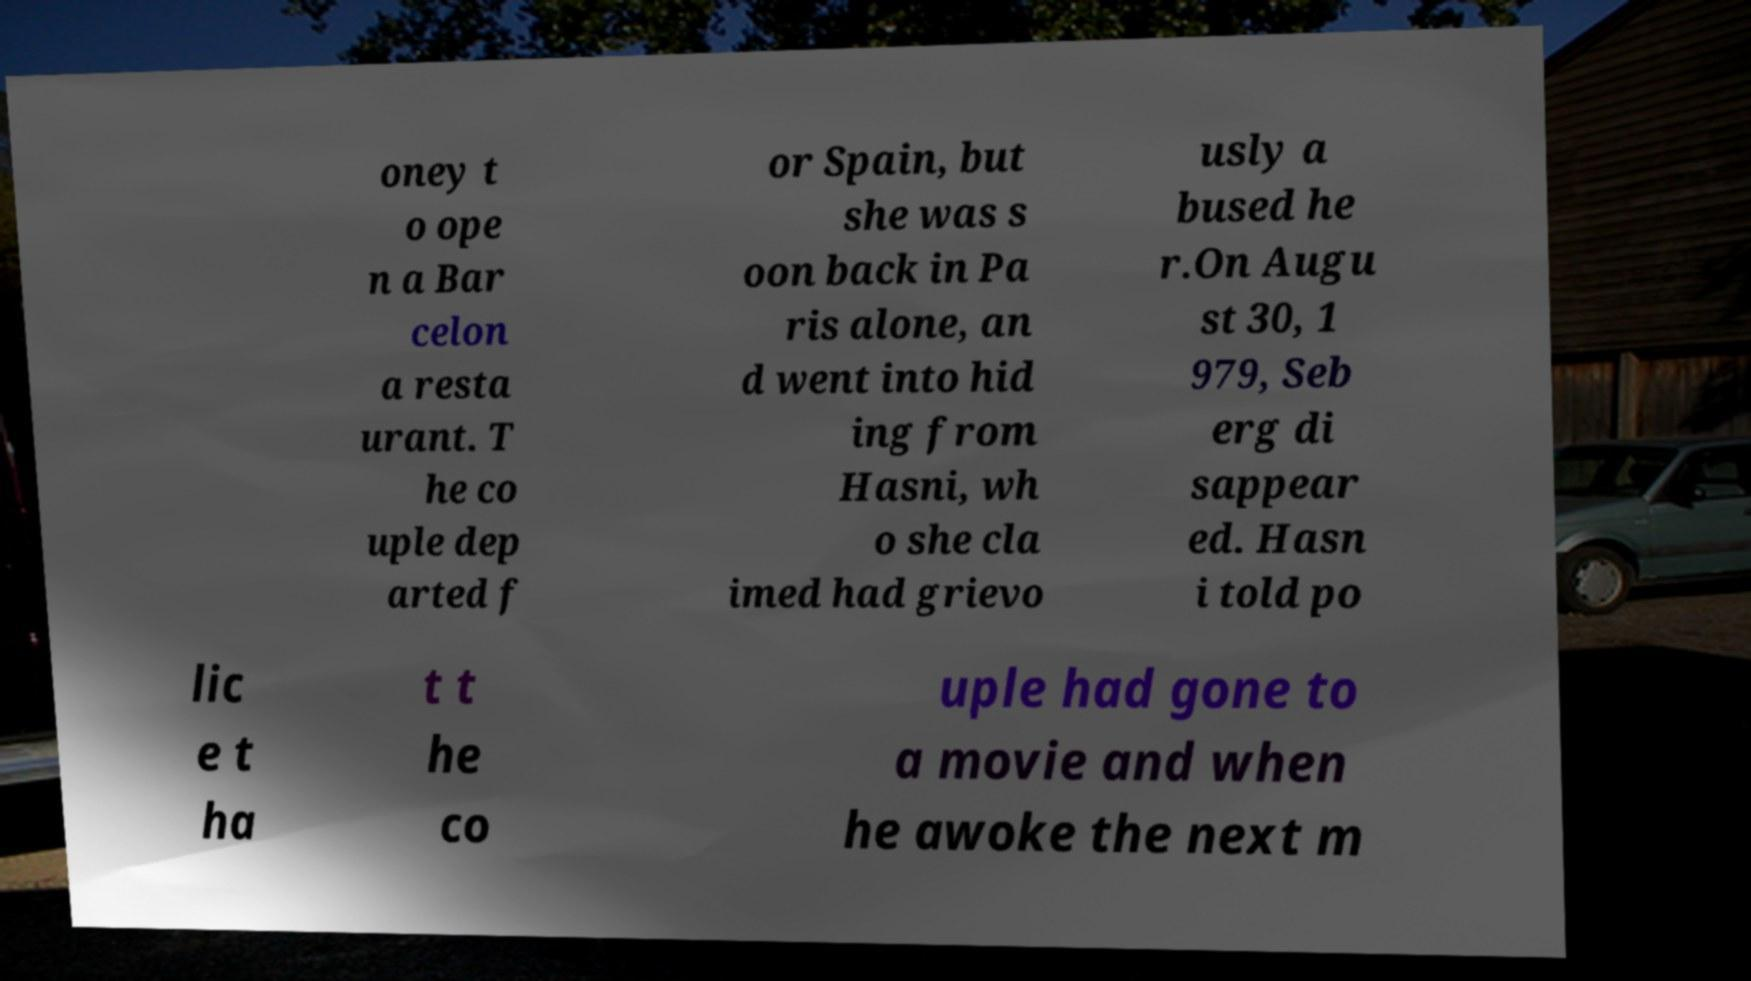Please identify and transcribe the text found in this image. oney t o ope n a Bar celon a resta urant. T he co uple dep arted f or Spain, but she was s oon back in Pa ris alone, an d went into hid ing from Hasni, wh o she cla imed had grievo usly a bused he r.On Augu st 30, 1 979, Seb erg di sappear ed. Hasn i told po lic e t ha t t he co uple had gone to a movie and when he awoke the next m 